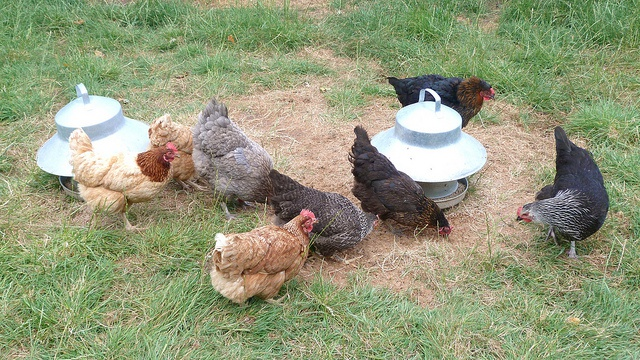Describe the objects in this image and their specific colors. I can see bird in green, gray, and tan tones, bird in green, darkgray, gray, and lightgray tones, bird in green, gray, black, and darkgray tones, bird in green, ivory, tan, and brown tones, and bird in green, black, gray, and maroon tones in this image. 